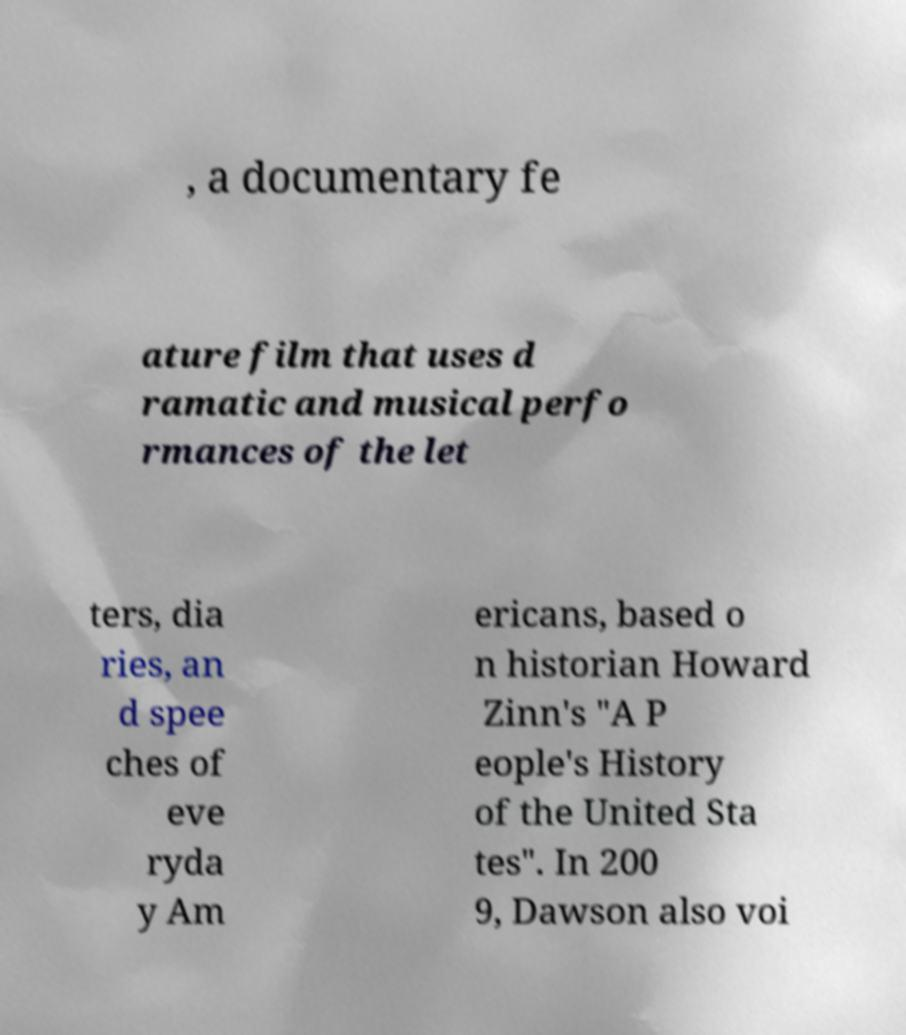Please read and relay the text visible in this image. What does it say? , a documentary fe ature film that uses d ramatic and musical perfo rmances of the let ters, dia ries, an d spee ches of eve ryda y Am ericans, based o n historian Howard Zinn's "A P eople's History of the United Sta tes". In 200 9, Dawson also voi 